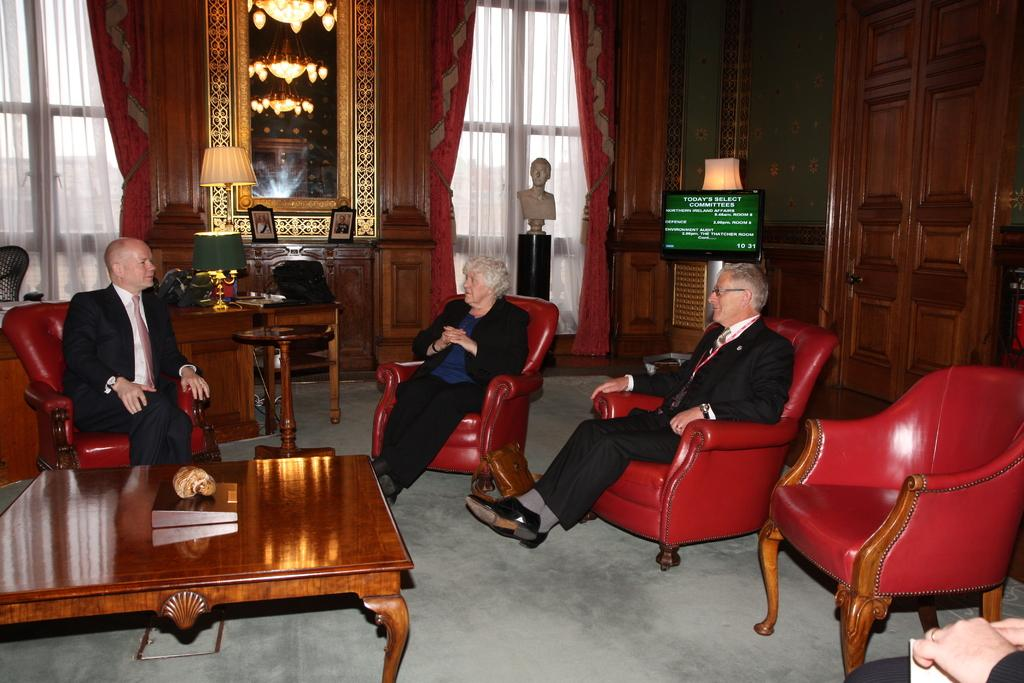What are the people in the image doing? The people in the image are sitting on chairs. What color are the chairs? The chairs are red in color. What type of furniture is present on the table in the image? There is a wooden table in the image. What object can be seen on the table? There is a book on the table. What can be seen in the background of the image? There is a TV in the background. How many balloons are floating above the people in the image? There are no balloons visible in the image. What type of ray is swimming in the background of the image? There is no ray present in the image; it is an indoor setting with a TV in the background. 